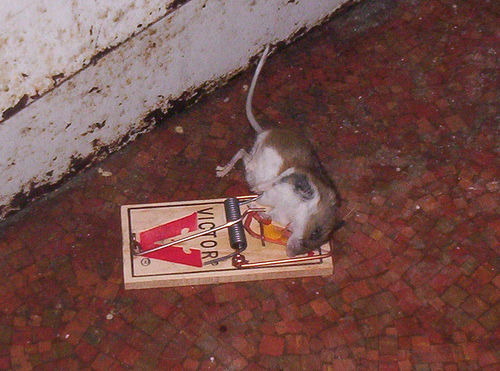<image>
Is there a ground under the mouse? Yes. The ground is positioned underneath the mouse, with the mouse above it in the vertical space. Is there a mouse on the trap? Yes. Looking at the image, I can see the mouse is positioned on top of the trap, with the trap providing support. 